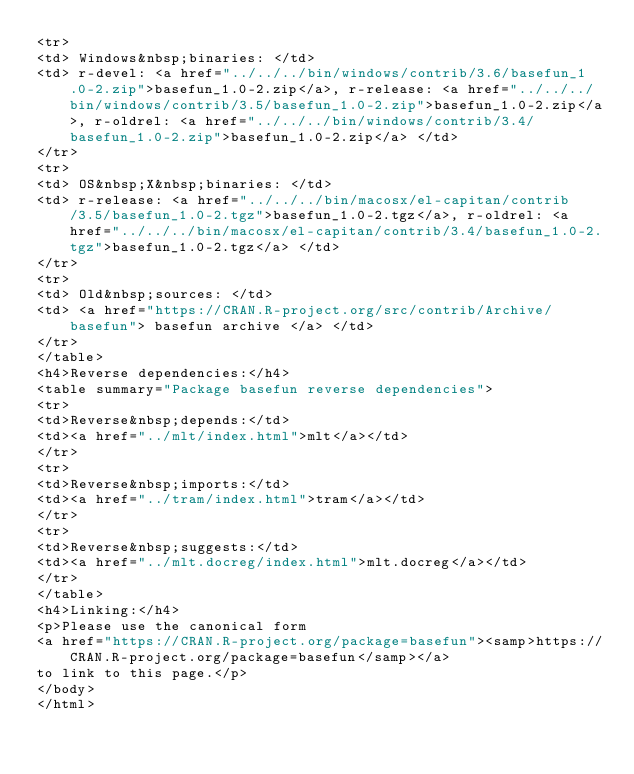<code> <loc_0><loc_0><loc_500><loc_500><_HTML_><tr>
<td> Windows&nbsp;binaries: </td>
<td> r-devel: <a href="../../../bin/windows/contrib/3.6/basefun_1.0-2.zip">basefun_1.0-2.zip</a>, r-release: <a href="../../../bin/windows/contrib/3.5/basefun_1.0-2.zip">basefun_1.0-2.zip</a>, r-oldrel: <a href="../../../bin/windows/contrib/3.4/basefun_1.0-2.zip">basefun_1.0-2.zip</a> </td>
</tr>
<tr>
<td> OS&nbsp;X&nbsp;binaries: </td>
<td> r-release: <a href="../../../bin/macosx/el-capitan/contrib/3.5/basefun_1.0-2.tgz">basefun_1.0-2.tgz</a>, r-oldrel: <a href="../../../bin/macosx/el-capitan/contrib/3.4/basefun_1.0-2.tgz">basefun_1.0-2.tgz</a> </td>
</tr>
<tr>
<td> Old&nbsp;sources: </td>
<td> <a href="https://CRAN.R-project.org/src/contrib/Archive/basefun"> basefun archive </a> </td>
</tr>
</table>
<h4>Reverse dependencies:</h4>
<table summary="Package basefun reverse dependencies">
<tr>
<td>Reverse&nbsp;depends:</td>
<td><a href="../mlt/index.html">mlt</a></td>
</tr>
<tr>
<td>Reverse&nbsp;imports:</td>
<td><a href="../tram/index.html">tram</a></td>
</tr>
<tr>
<td>Reverse&nbsp;suggests:</td>
<td><a href="../mlt.docreg/index.html">mlt.docreg</a></td>
</tr>
</table>
<h4>Linking:</h4>
<p>Please use the canonical form
<a href="https://CRAN.R-project.org/package=basefun"><samp>https://CRAN.R-project.org/package=basefun</samp></a>
to link to this page.</p>
</body>
</html>
</code> 